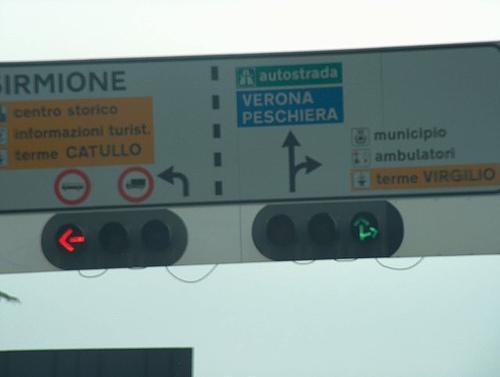How many traffic lights can you see?
Give a very brief answer. 2. 